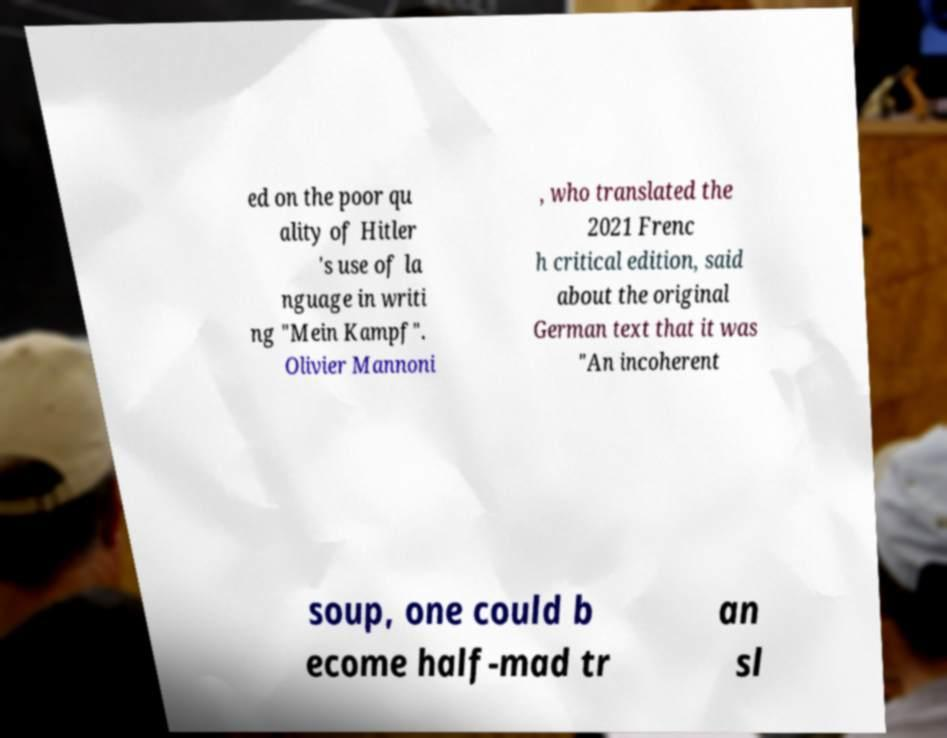Can you accurately transcribe the text from the provided image for me? ed on the poor qu ality of Hitler 's use of la nguage in writi ng "Mein Kampf". Olivier Mannoni , who translated the 2021 Frenc h critical edition, said about the original German text that it was "An incoherent soup, one could b ecome half-mad tr an sl 